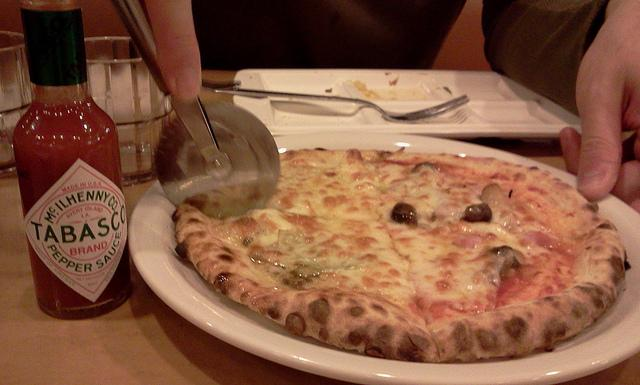The popular American brand of hot sauce is made up of what? Please explain your reasoning. tabasco peppers. It says on the bottle. 